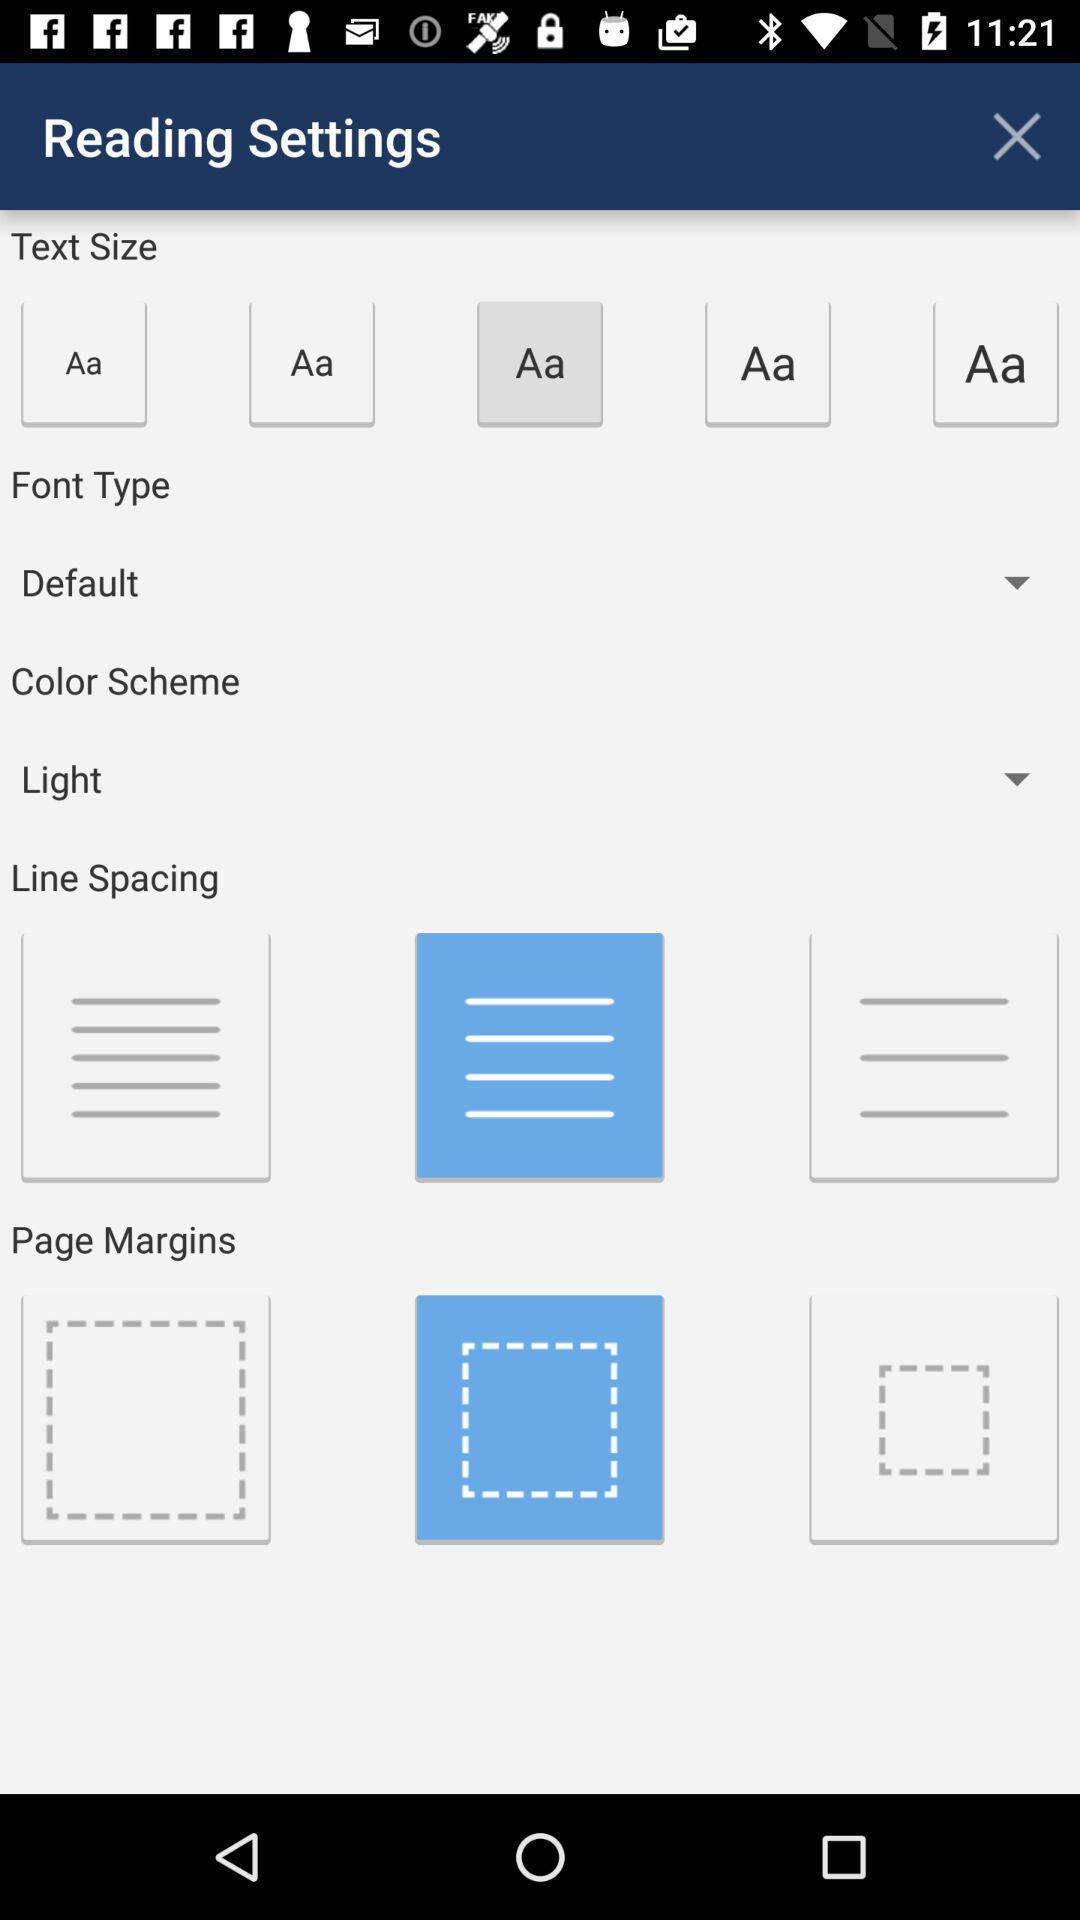Give me a narrative description of this picture. Text size setting displaying in this page. 